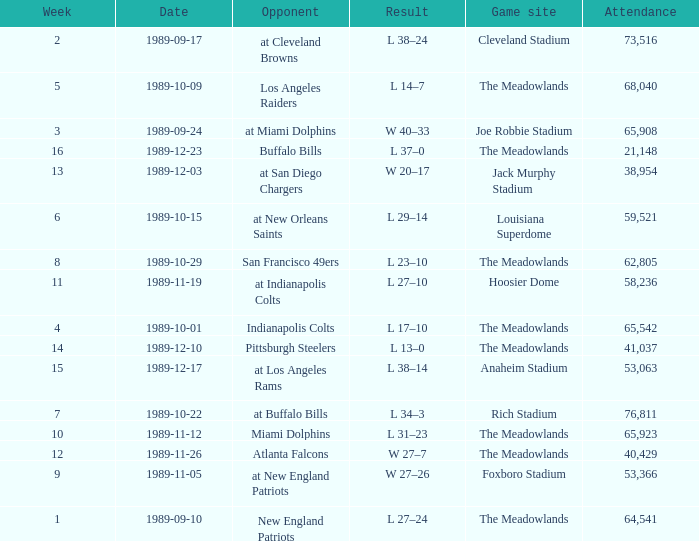What day did they play before week 2? 1989-09-10. 